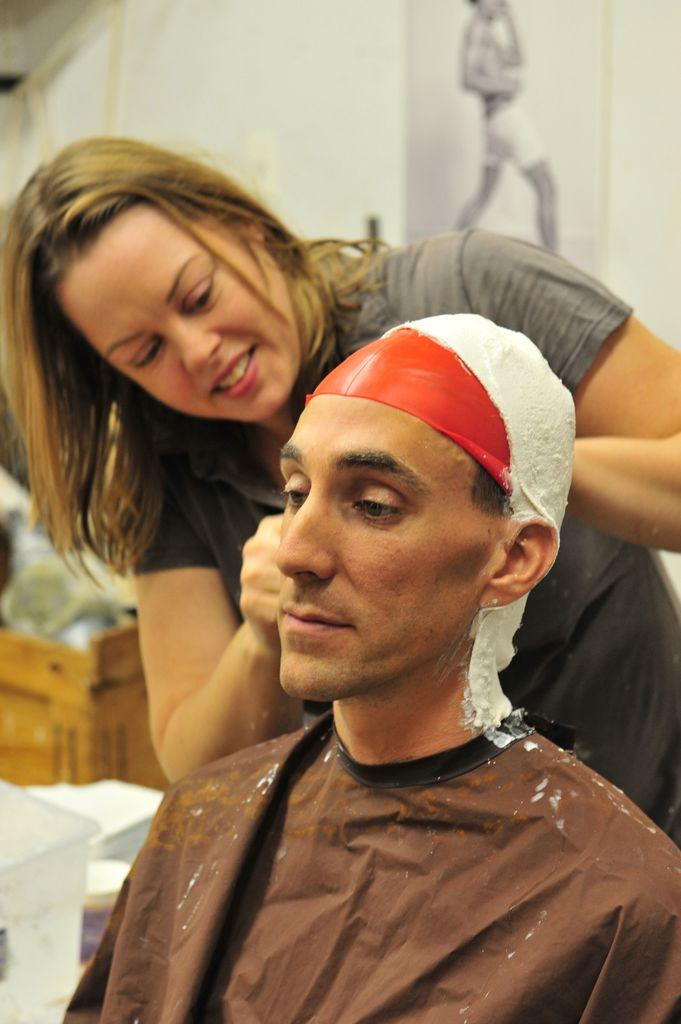How many people are in the image? There are two persons in the image. What are the persons wearing? Both persons are wearing dresses. Can you describe any accessories worn by the persons? One person is wearing a cap. What can be seen in the background of the image? There are containers placed on the ground and a photo frame on the wall in the background. What song is being sung by the persons in the image? There is no indication in the image that the persons are singing a song, so it cannot be determined from the picture. 